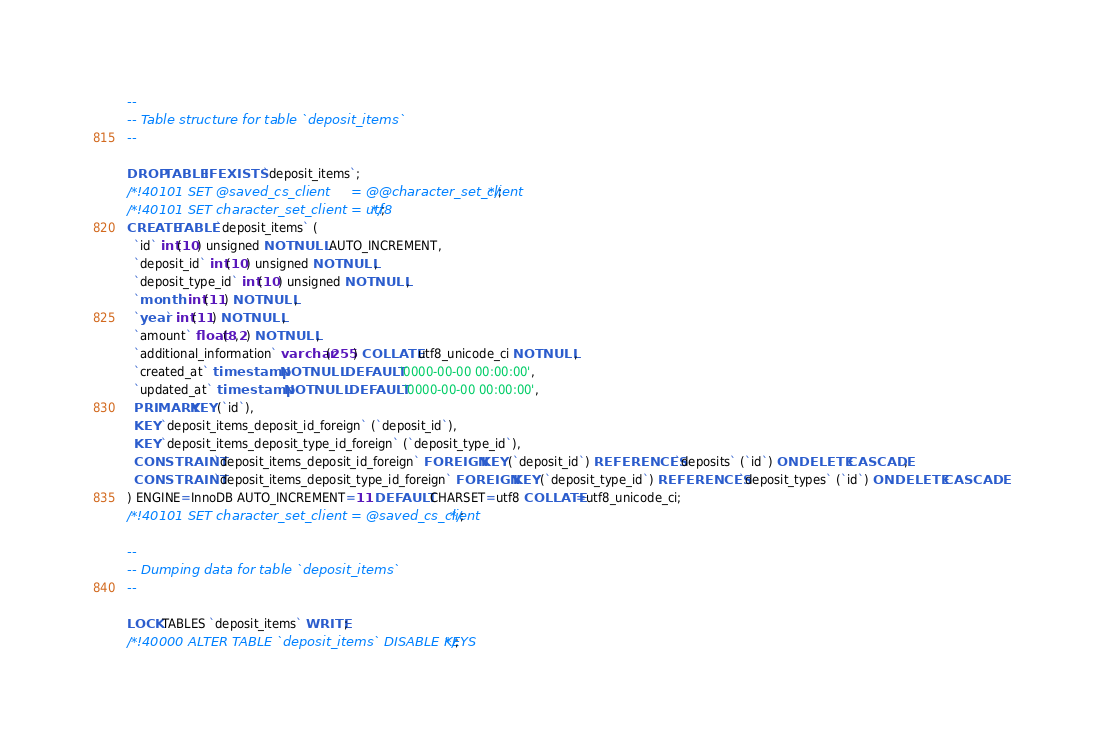Convert code to text. <code><loc_0><loc_0><loc_500><loc_500><_SQL_>--
-- Table structure for table `deposit_items`
--

DROP TABLE IF EXISTS `deposit_items`;
/*!40101 SET @saved_cs_client     = @@character_set_client */;
/*!40101 SET character_set_client = utf8 */;
CREATE TABLE `deposit_items` (
  `id` int(10) unsigned NOT NULL AUTO_INCREMENT,
  `deposit_id` int(10) unsigned NOT NULL,
  `deposit_type_id` int(10) unsigned NOT NULL,
  `month` int(11) NOT NULL,
  `year` int(11) NOT NULL,
  `amount` float(8,2) NOT NULL,
  `additional_information` varchar(255) COLLATE utf8_unicode_ci NOT NULL,
  `created_at` timestamp NOT NULL DEFAULT '0000-00-00 00:00:00',
  `updated_at` timestamp NOT NULL DEFAULT '0000-00-00 00:00:00',
  PRIMARY KEY (`id`),
  KEY `deposit_items_deposit_id_foreign` (`deposit_id`),
  KEY `deposit_items_deposit_type_id_foreign` (`deposit_type_id`),
  CONSTRAINT `deposit_items_deposit_id_foreign` FOREIGN KEY (`deposit_id`) REFERENCES `deposits` (`id`) ON DELETE CASCADE,
  CONSTRAINT `deposit_items_deposit_type_id_foreign` FOREIGN KEY (`deposit_type_id`) REFERENCES `deposit_types` (`id`) ON DELETE CASCADE
) ENGINE=InnoDB AUTO_INCREMENT=11 DEFAULT CHARSET=utf8 COLLATE=utf8_unicode_ci;
/*!40101 SET character_set_client = @saved_cs_client */;

--
-- Dumping data for table `deposit_items`
--

LOCK TABLES `deposit_items` WRITE;
/*!40000 ALTER TABLE `deposit_items` DISABLE KEYS */;</code> 